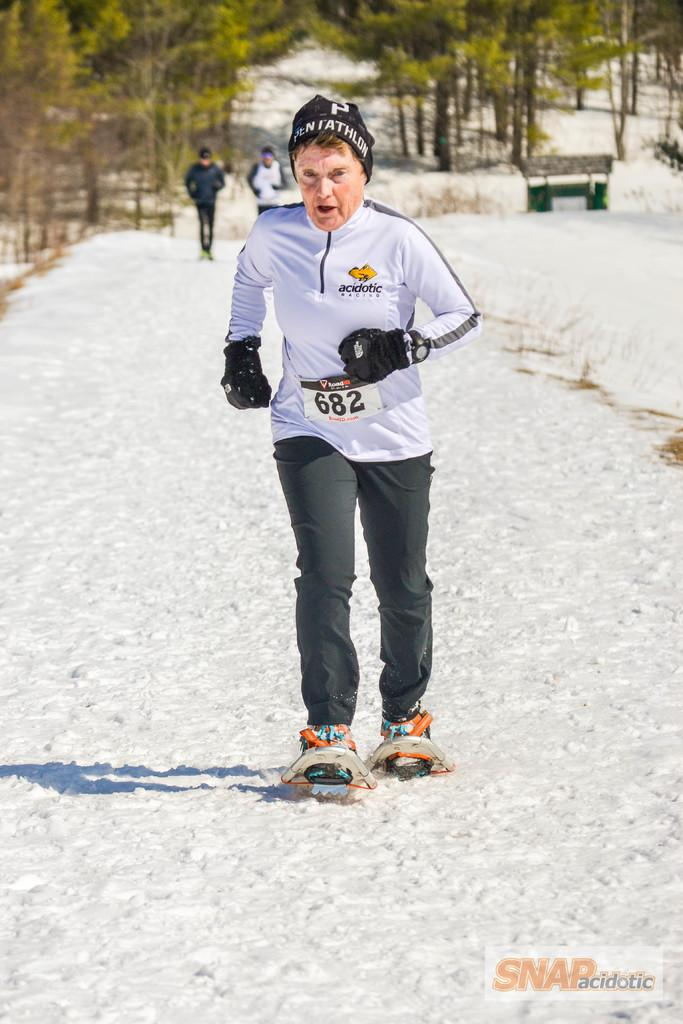How many people are in the image? There are three persons in the image. Can you describe the clothing of one of the persons? One person is wearing a white shirt and gray color pants. What is the background of the image like? In the background, there is snow, appearing white, and trees, appearing green. What type of whistle can be heard during the operation in the image? There is no operation or whistle present in the image; it features three persons and a snowy background with trees. 